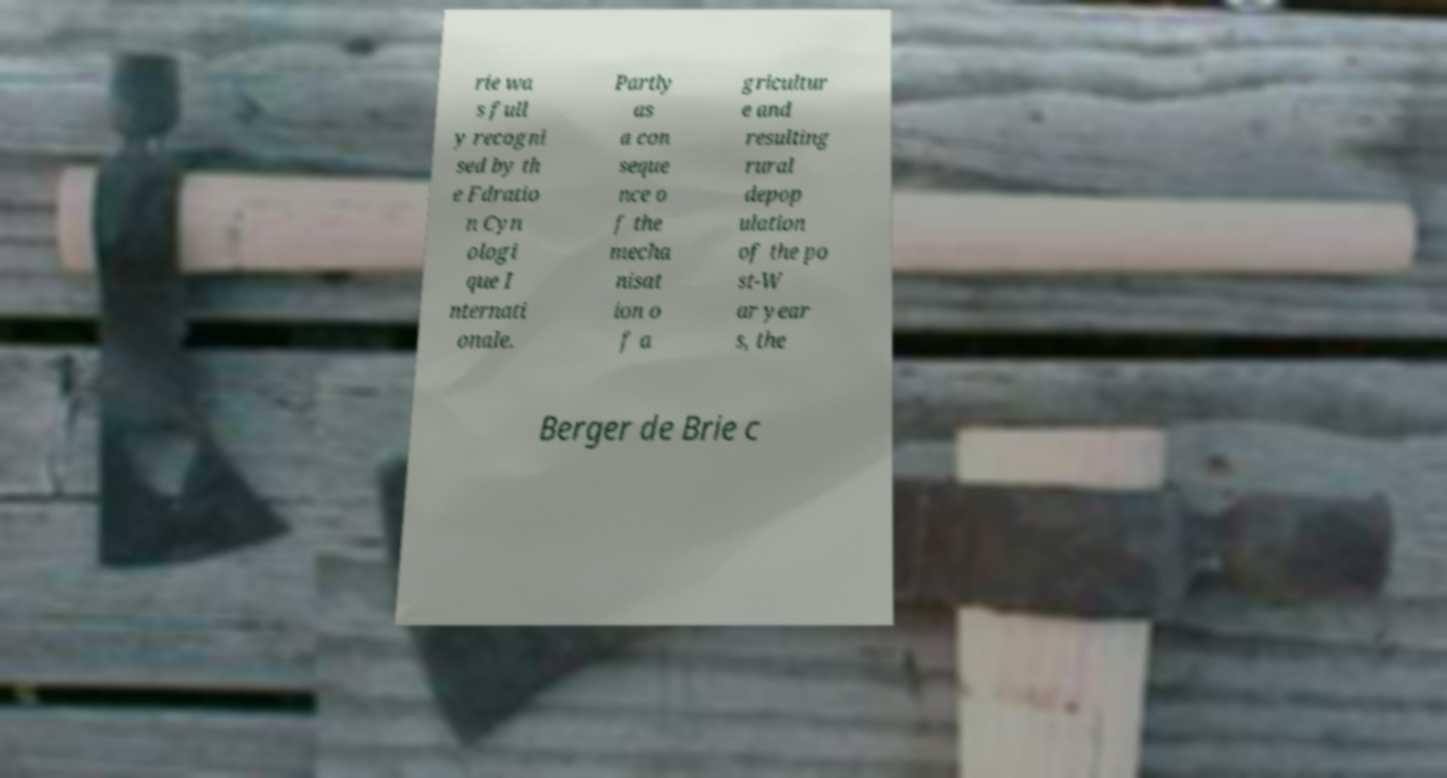Please identify and transcribe the text found in this image. rie wa s full y recogni sed by th e Fdratio n Cyn ologi que I nternati onale. Partly as a con seque nce o f the mecha nisat ion o f a gricultur e and resulting rural depop ulation of the po st-W ar year s, the Berger de Brie c 